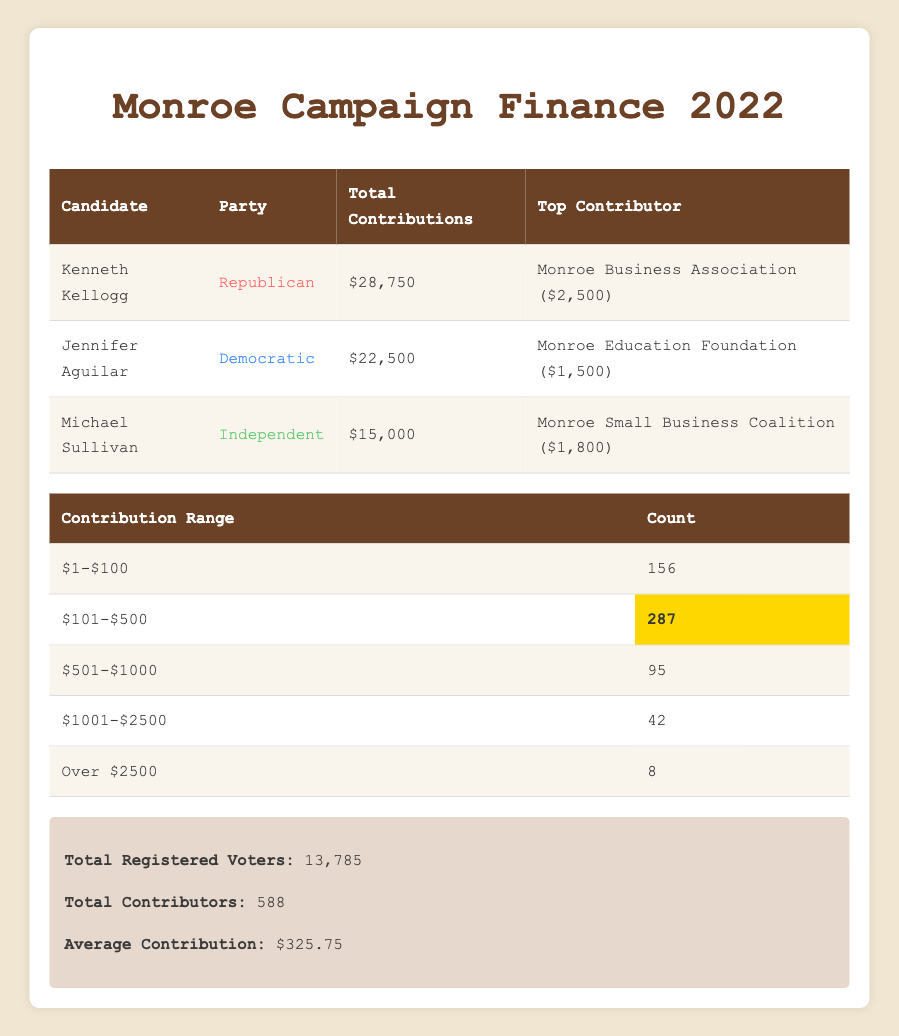What is the total contribution amount for Kenneth Kellogg? In the table, under Kenneth Kellogg's row, the total contributions are listed as $28,750.
Answer: $28,750 Who was the top contributor for Jennifer Aguilar? The table indicates that Jennifer Aguilar's top contributor is the Monroe Education Foundation, which contributed $1,500.
Answer: Monroe Education Foundation How many contributors gave amounts over $1,000? By looking at the contribution ranges in the second table, the range '$1001-$2500' has 42 contributors, and there are 8 contributors in the range 'Over $2500', adding them gives 42 + 8 = 50 contributors over $1,000.
Answer: 50 Which candidate received the least total contributions? Comparing the total contributions from all candidates: Kenneth Kellogg received $28,750, Jennifer Aguilar received $22,500, and Michael Sullivan received $15,000. Michael Sullivan has the lowest amount at $15,000.
Answer: Michael Sullivan Is it true that the average contribution is higher than $300? The table states that the average contribution is $325.75, which is indeed higher than $300. Therefore, the statement is true.
Answer: Yes What is the total number of contributors for all candidates combined? The total number of contributors is provided in the info box at the bottom of the table, which states there are 588 total contributors for all candidates combined.
Answer: 588 Calculate the combined total contributions of the Democratic candidates. The total contribution for the Democratic candidate, Jennifer Aguilar, is $22,500. Since she is the only Democratic candidate in the data, the combined total is simply $22,500.
Answer: $22,500 How many contributions were made in the range of $101 to $500? The contribution ranges table shows that the count of contributions in the range $101-$500 is 287.
Answer: 287 